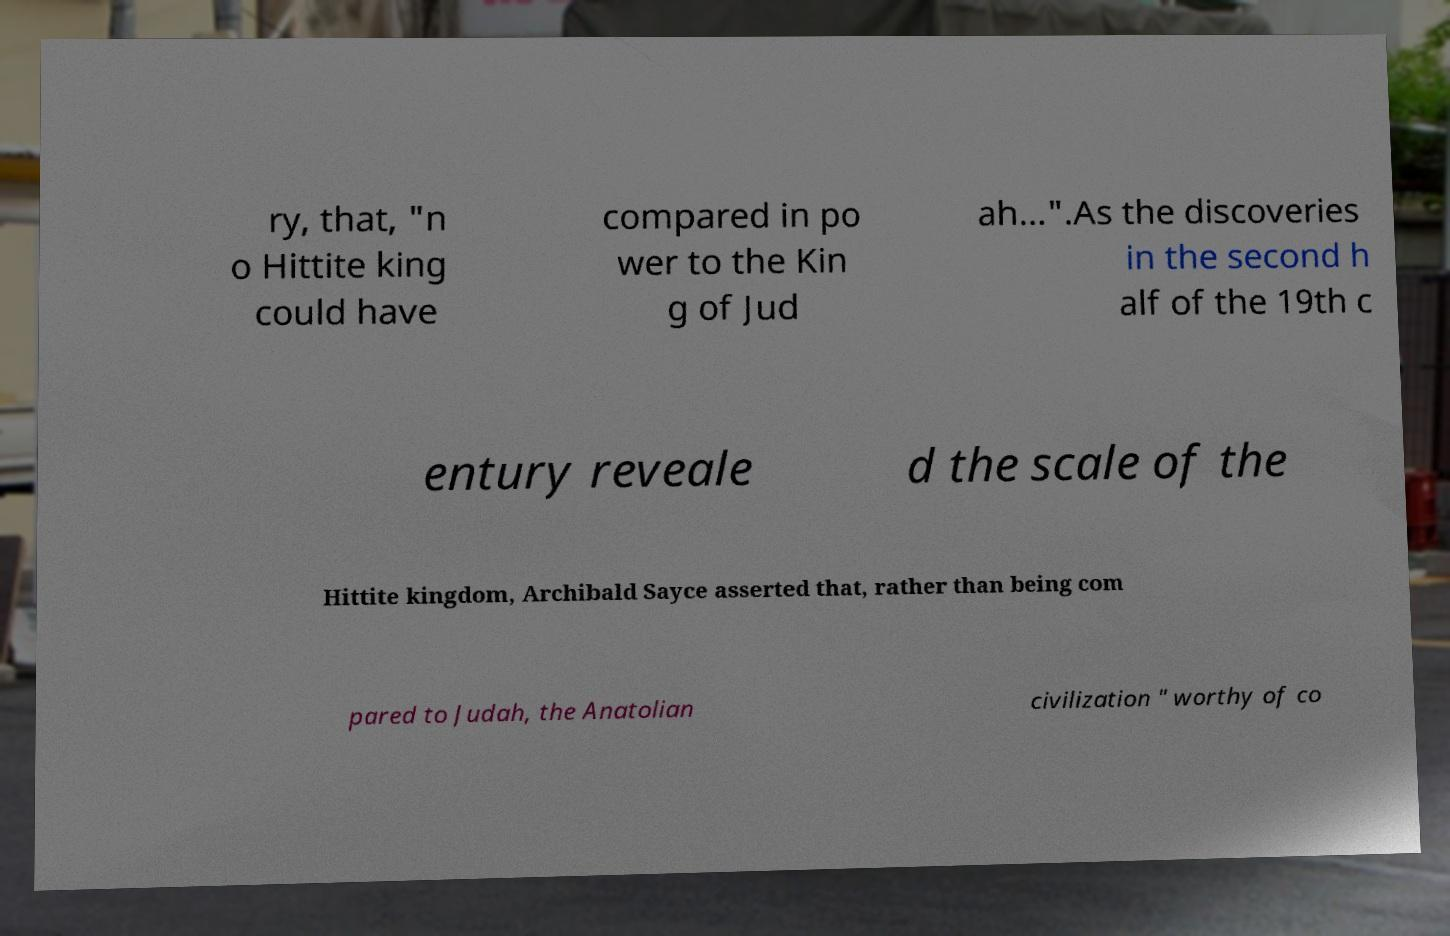Please read and relay the text visible in this image. What does it say? ry, that, "n o Hittite king could have compared in po wer to the Kin g of Jud ah...".As the discoveries in the second h alf of the 19th c entury reveale d the scale of the Hittite kingdom, Archibald Sayce asserted that, rather than being com pared to Judah, the Anatolian civilization " worthy of co 